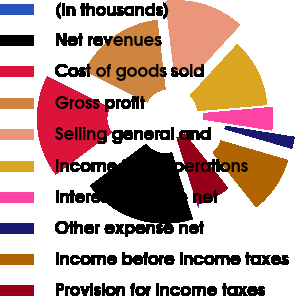<chart> <loc_0><loc_0><loc_500><loc_500><pie_chart><fcel>(In thousands)<fcel>Net revenues<fcel>Cost of goods sold<fcel>Gross profit<fcel>Selling general and<fcel>Income from operations<fcel>Interest expense net<fcel>Other expense net<fcel>Income before income taxes<fcel>Provision for income taxes<nl><fcel>0.01%<fcel>19.6%<fcel>17.64%<fcel>15.68%<fcel>13.72%<fcel>11.76%<fcel>3.93%<fcel>1.97%<fcel>9.8%<fcel>5.89%<nl></chart> 